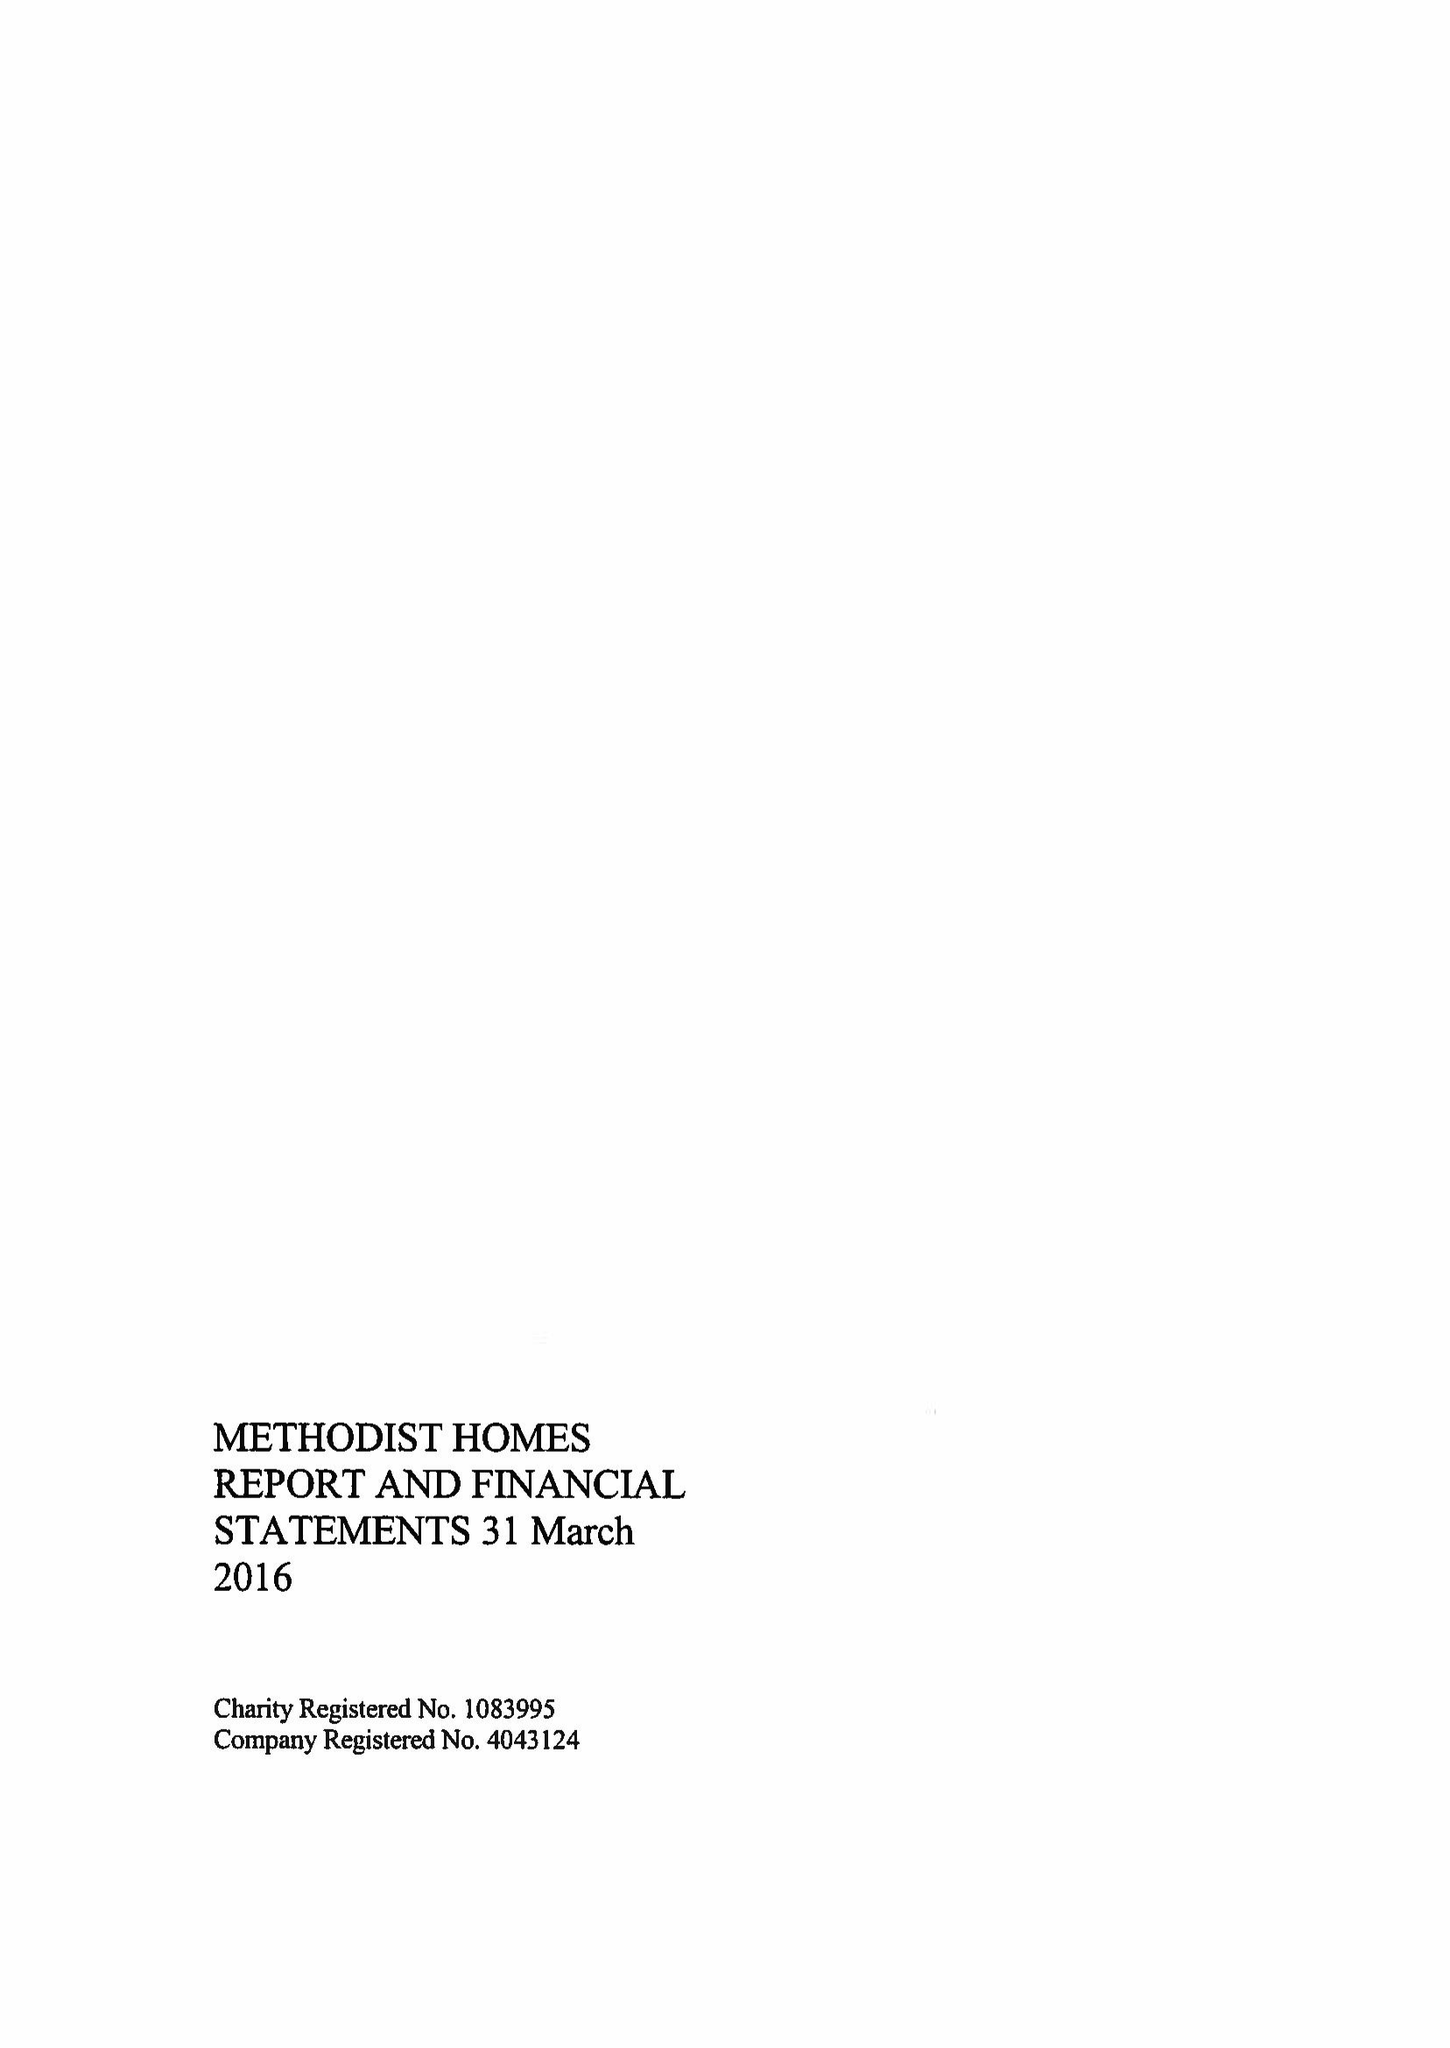What is the value for the charity_number?
Answer the question using a single word or phrase. 1083995 